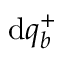<formula> <loc_0><loc_0><loc_500><loc_500>d q _ { b } ^ { + }</formula> 